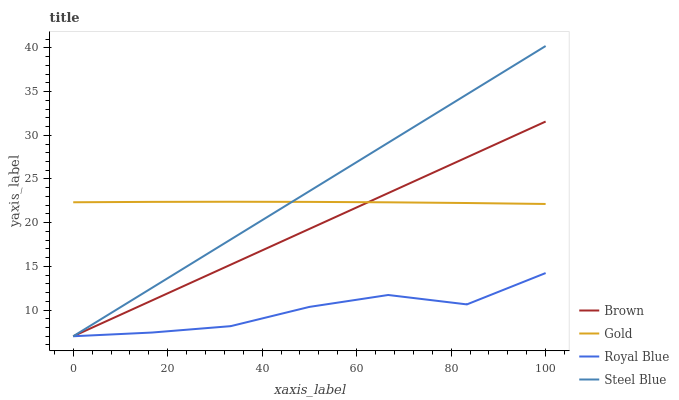Does Gold have the minimum area under the curve?
Answer yes or no. No. Does Gold have the maximum area under the curve?
Answer yes or no. No. Is Gold the smoothest?
Answer yes or no. No. Is Gold the roughest?
Answer yes or no. No. Does Gold have the lowest value?
Answer yes or no. No. Does Gold have the highest value?
Answer yes or no. No. Is Royal Blue less than Gold?
Answer yes or no. Yes. Is Gold greater than Royal Blue?
Answer yes or no. Yes. Does Royal Blue intersect Gold?
Answer yes or no. No. 